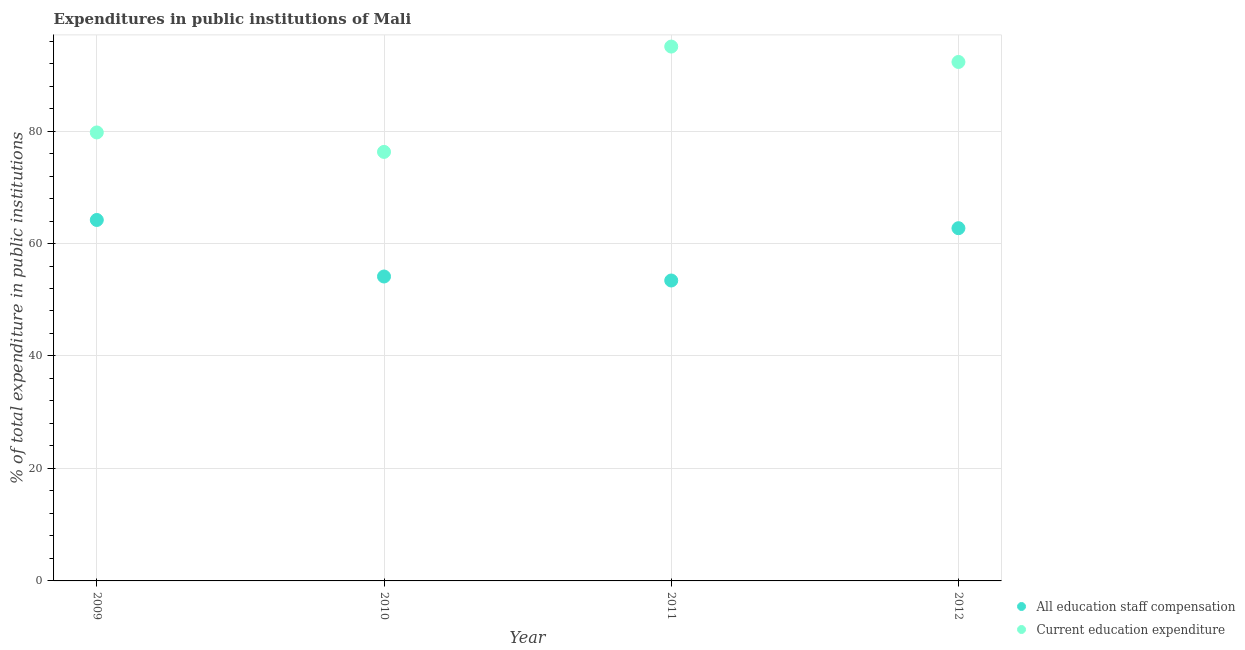How many different coloured dotlines are there?
Provide a short and direct response. 2. Is the number of dotlines equal to the number of legend labels?
Give a very brief answer. Yes. What is the expenditure in education in 2011?
Your answer should be very brief. 95.02. Across all years, what is the maximum expenditure in education?
Offer a terse response. 95.02. Across all years, what is the minimum expenditure in education?
Provide a short and direct response. 76.29. In which year was the expenditure in education maximum?
Your response must be concise. 2011. What is the total expenditure in staff compensation in the graph?
Keep it short and to the point. 234.46. What is the difference between the expenditure in education in 2010 and that in 2012?
Provide a short and direct response. -15.99. What is the difference between the expenditure in education in 2010 and the expenditure in staff compensation in 2009?
Your answer should be compact. 12.1. What is the average expenditure in staff compensation per year?
Offer a terse response. 58.62. In the year 2010, what is the difference between the expenditure in education and expenditure in staff compensation?
Your answer should be compact. 22.16. In how many years, is the expenditure in education greater than 28 %?
Offer a terse response. 4. What is the ratio of the expenditure in staff compensation in 2009 to that in 2011?
Keep it short and to the point. 1.2. Is the expenditure in staff compensation in 2011 less than that in 2012?
Offer a very short reply. Yes. What is the difference between the highest and the second highest expenditure in staff compensation?
Offer a very short reply. 1.46. What is the difference between the highest and the lowest expenditure in education?
Keep it short and to the point. 18.73. Does the expenditure in education monotonically increase over the years?
Make the answer very short. No. Is the expenditure in staff compensation strictly greater than the expenditure in education over the years?
Your answer should be very brief. No. How many dotlines are there?
Your answer should be very brief. 2. How many years are there in the graph?
Offer a very short reply. 4. How are the legend labels stacked?
Offer a very short reply. Vertical. What is the title of the graph?
Offer a terse response. Expenditures in public institutions of Mali. Does "Banks" appear as one of the legend labels in the graph?
Provide a succinct answer. No. What is the label or title of the X-axis?
Your response must be concise. Year. What is the label or title of the Y-axis?
Provide a short and direct response. % of total expenditure in public institutions. What is the % of total expenditure in public institutions of All education staff compensation in 2009?
Ensure brevity in your answer.  64.19. What is the % of total expenditure in public institutions of Current education expenditure in 2009?
Offer a terse response. 79.75. What is the % of total expenditure in public institutions in All education staff compensation in 2010?
Provide a succinct answer. 54.13. What is the % of total expenditure in public institutions of Current education expenditure in 2010?
Your answer should be very brief. 76.29. What is the % of total expenditure in public institutions in All education staff compensation in 2011?
Provide a short and direct response. 53.42. What is the % of total expenditure in public institutions in Current education expenditure in 2011?
Offer a terse response. 95.02. What is the % of total expenditure in public institutions of All education staff compensation in 2012?
Your answer should be compact. 62.72. What is the % of total expenditure in public institutions of Current education expenditure in 2012?
Ensure brevity in your answer.  92.28. Across all years, what is the maximum % of total expenditure in public institutions in All education staff compensation?
Offer a very short reply. 64.19. Across all years, what is the maximum % of total expenditure in public institutions of Current education expenditure?
Offer a very short reply. 95.02. Across all years, what is the minimum % of total expenditure in public institutions in All education staff compensation?
Ensure brevity in your answer.  53.42. Across all years, what is the minimum % of total expenditure in public institutions in Current education expenditure?
Keep it short and to the point. 76.29. What is the total % of total expenditure in public institutions in All education staff compensation in the graph?
Your response must be concise. 234.46. What is the total % of total expenditure in public institutions in Current education expenditure in the graph?
Your response must be concise. 343.34. What is the difference between the % of total expenditure in public institutions of All education staff compensation in 2009 and that in 2010?
Provide a short and direct response. 10.05. What is the difference between the % of total expenditure in public institutions in Current education expenditure in 2009 and that in 2010?
Offer a very short reply. 3.46. What is the difference between the % of total expenditure in public institutions in All education staff compensation in 2009 and that in 2011?
Ensure brevity in your answer.  10.76. What is the difference between the % of total expenditure in public institutions in Current education expenditure in 2009 and that in 2011?
Your answer should be compact. -15.27. What is the difference between the % of total expenditure in public institutions of All education staff compensation in 2009 and that in 2012?
Keep it short and to the point. 1.46. What is the difference between the % of total expenditure in public institutions of Current education expenditure in 2009 and that in 2012?
Your response must be concise. -12.53. What is the difference between the % of total expenditure in public institutions in All education staff compensation in 2010 and that in 2011?
Provide a short and direct response. 0.71. What is the difference between the % of total expenditure in public institutions of Current education expenditure in 2010 and that in 2011?
Give a very brief answer. -18.73. What is the difference between the % of total expenditure in public institutions in All education staff compensation in 2010 and that in 2012?
Ensure brevity in your answer.  -8.59. What is the difference between the % of total expenditure in public institutions in Current education expenditure in 2010 and that in 2012?
Offer a very short reply. -15.99. What is the difference between the % of total expenditure in public institutions of All education staff compensation in 2011 and that in 2012?
Provide a short and direct response. -9.3. What is the difference between the % of total expenditure in public institutions in Current education expenditure in 2011 and that in 2012?
Make the answer very short. 2.74. What is the difference between the % of total expenditure in public institutions in All education staff compensation in 2009 and the % of total expenditure in public institutions in Current education expenditure in 2010?
Your response must be concise. -12.1. What is the difference between the % of total expenditure in public institutions of All education staff compensation in 2009 and the % of total expenditure in public institutions of Current education expenditure in 2011?
Provide a short and direct response. -30.83. What is the difference between the % of total expenditure in public institutions of All education staff compensation in 2009 and the % of total expenditure in public institutions of Current education expenditure in 2012?
Keep it short and to the point. -28.1. What is the difference between the % of total expenditure in public institutions of All education staff compensation in 2010 and the % of total expenditure in public institutions of Current education expenditure in 2011?
Provide a short and direct response. -40.89. What is the difference between the % of total expenditure in public institutions in All education staff compensation in 2010 and the % of total expenditure in public institutions in Current education expenditure in 2012?
Ensure brevity in your answer.  -38.15. What is the difference between the % of total expenditure in public institutions of All education staff compensation in 2011 and the % of total expenditure in public institutions of Current education expenditure in 2012?
Offer a very short reply. -38.86. What is the average % of total expenditure in public institutions in All education staff compensation per year?
Your response must be concise. 58.62. What is the average % of total expenditure in public institutions in Current education expenditure per year?
Provide a succinct answer. 85.83. In the year 2009, what is the difference between the % of total expenditure in public institutions in All education staff compensation and % of total expenditure in public institutions in Current education expenditure?
Give a very brief answer. -15.56. In the year 2010, what is the difference between the % of total expenditure in public institutions of All education staff compensation and % of total expenditure in public institutions of Current education expenditure?
Your answer should be very brief. -22.16. In the year 2011, what is the difference between the % of total expenditure in public institutions of All education staff compensation and % of total expenditure in public institutions of Current education expenditure?
Offer a terse response. -41.6. In the year 2012, what is the difference between the % of total expenditure in public institutions of All education staff compensation and % of total expenditure in public institutions of Current education expenditure?
Ensure brevity in your answer.  -29.56. What is the ratio of the % of total expenditure in public institutions of All education staff compensation in 2009 to that in 2010?
Give a very brief answer. 1.19. What is the ratio of the % of total expenditure in public institutions in Current education expenditure in 2009 to that in 2010?
Give a very brief answer. 1.05. What is the ratio of the % of total expenditure in public institutions of All education staff compensation in 2009 to that in 2011?
Your answer should be very brief. 1.2. What is the ratio of the % of total expenditure in public institutions of Current education expenditure in 2009 to that in 2011?
Provide a succinct answer. 0.84. What is the ratio of the % of total expenditure in public institutions of All education staff compensation in 2009 to that in 2012?
Your response must be concise. 1.02. What is the ratio of the % of total expenditure in public institutions of Current education expenditure in 2009 to that in 2012?
Keep it short and to the point. 0.86. What is the ratio of the % of total expenditure in public institutions of All education staff compensation in 2010 to that in 2011?
Your answer should be very brief. 1.01. What is the ratio of the % of total expenditure in public institutions of Current education expenditure in 2010 to that in 2011?
Provide a short and direct response. 0.8. What is the ratio of the % of total expenditure in public institutions in All education staff compensation in 2010 to that in 2012?
Your response must be concise. 0.86. What is the ratio of the % of total expenditure in public institutions in Current education expenditure in 2010 to that in 2012?
Your response must be concise. 0.83. What is the ratio of the % of total expenditure in public institutions of All education staff compensation in 2011 to that in 2012?
Your response must be concise. 0.85. What is the ratio of the % of total expenditure in public institutions of Current education expenditure in 2011 to that in 2012?
Offer a very short reply. 1.03. What is the difference between the highest and the second highest % of total expenditure in public institutions of All education staff compensation?
Give a very brief answer. 1.46. What is the difference between the highest and the second highest % of total expenditure in public institutions in Current education expenditure?
Give a very brief answer. 2.74. What is the difference between the highest and the lowest % of total expenditure in public institutions of All education staff compensation?
Give a very brief answer. 10.76. What is the difference between the highest and the lowest % of total expenditure in public institutions of Current education expenditure?
Keep it short and to the point. 18.73. 